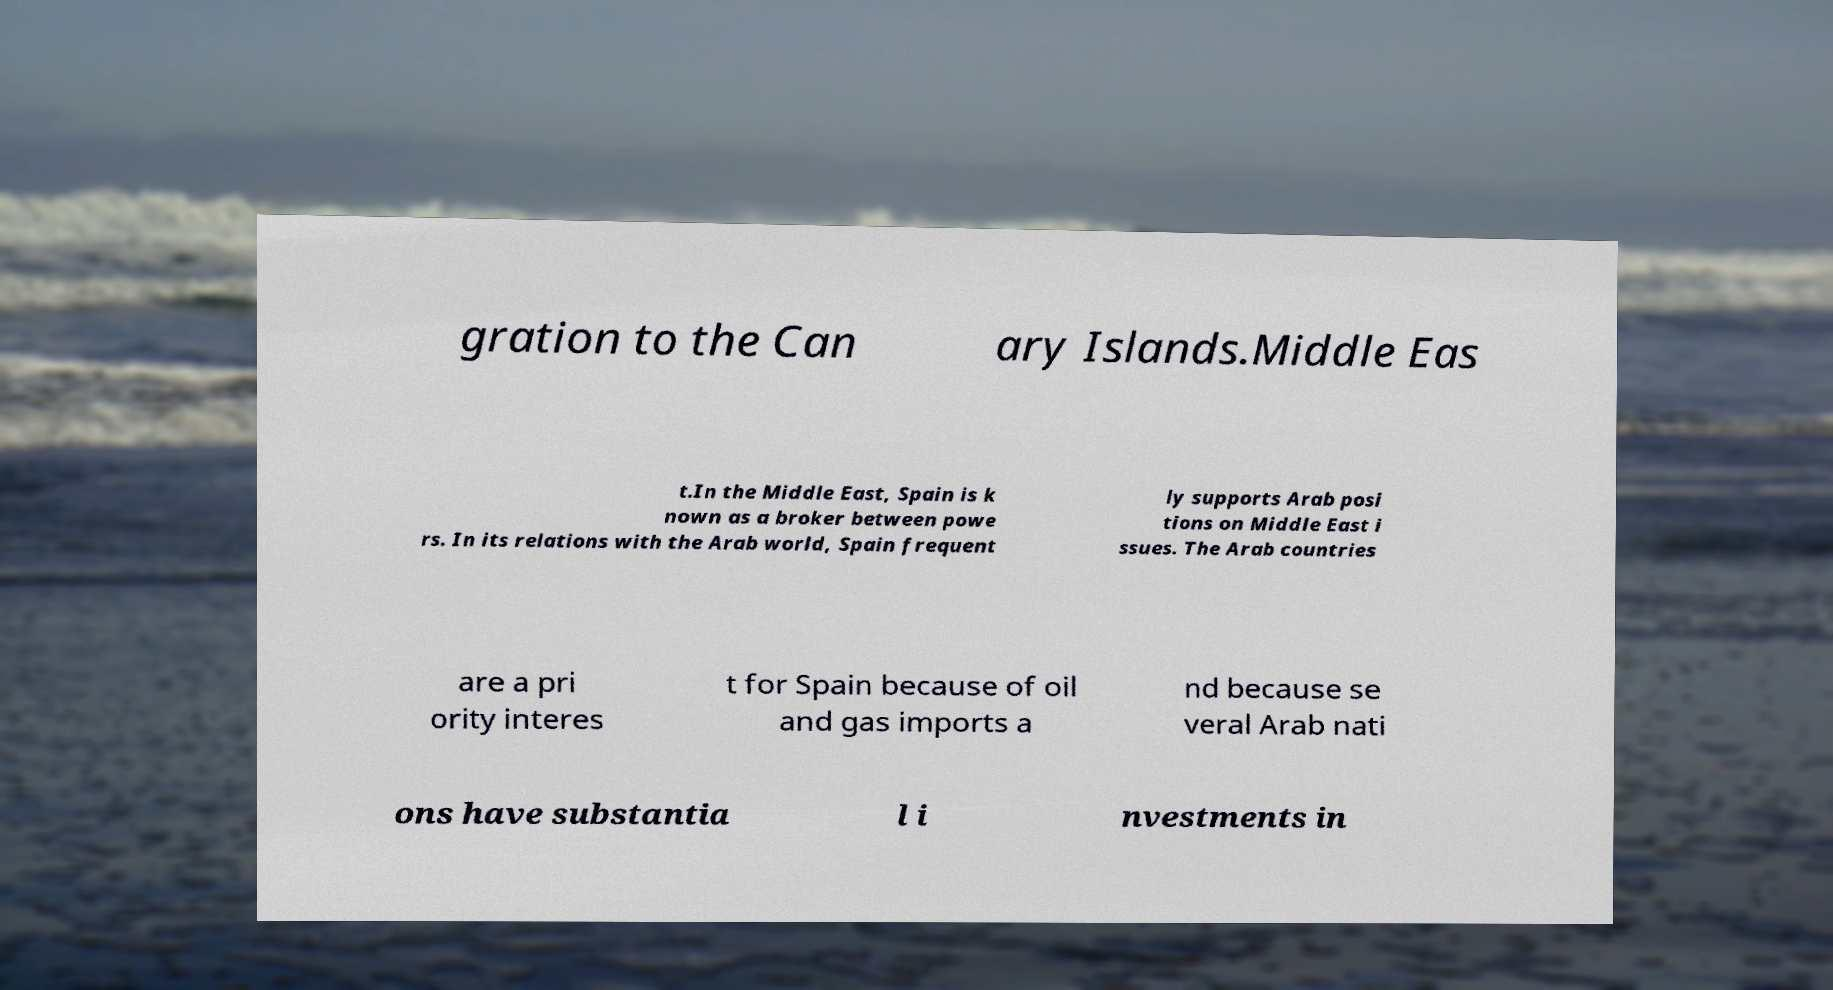There's text embedded in this image that I need extracted. Can you transcribe it verbatim? gration to the Can ary Islands.Middle Eas t.In the Middle East, Spain is k nown as a broker between powe rs. In its relations with the Arab world, Spain frequent ly supports Arab posi tions on Middle East i ssues. The Arab countries are a pri ority interes t for Spain because of oil and gas imports a nd because se veral Arab nati ons have substantia l i nvestments in 